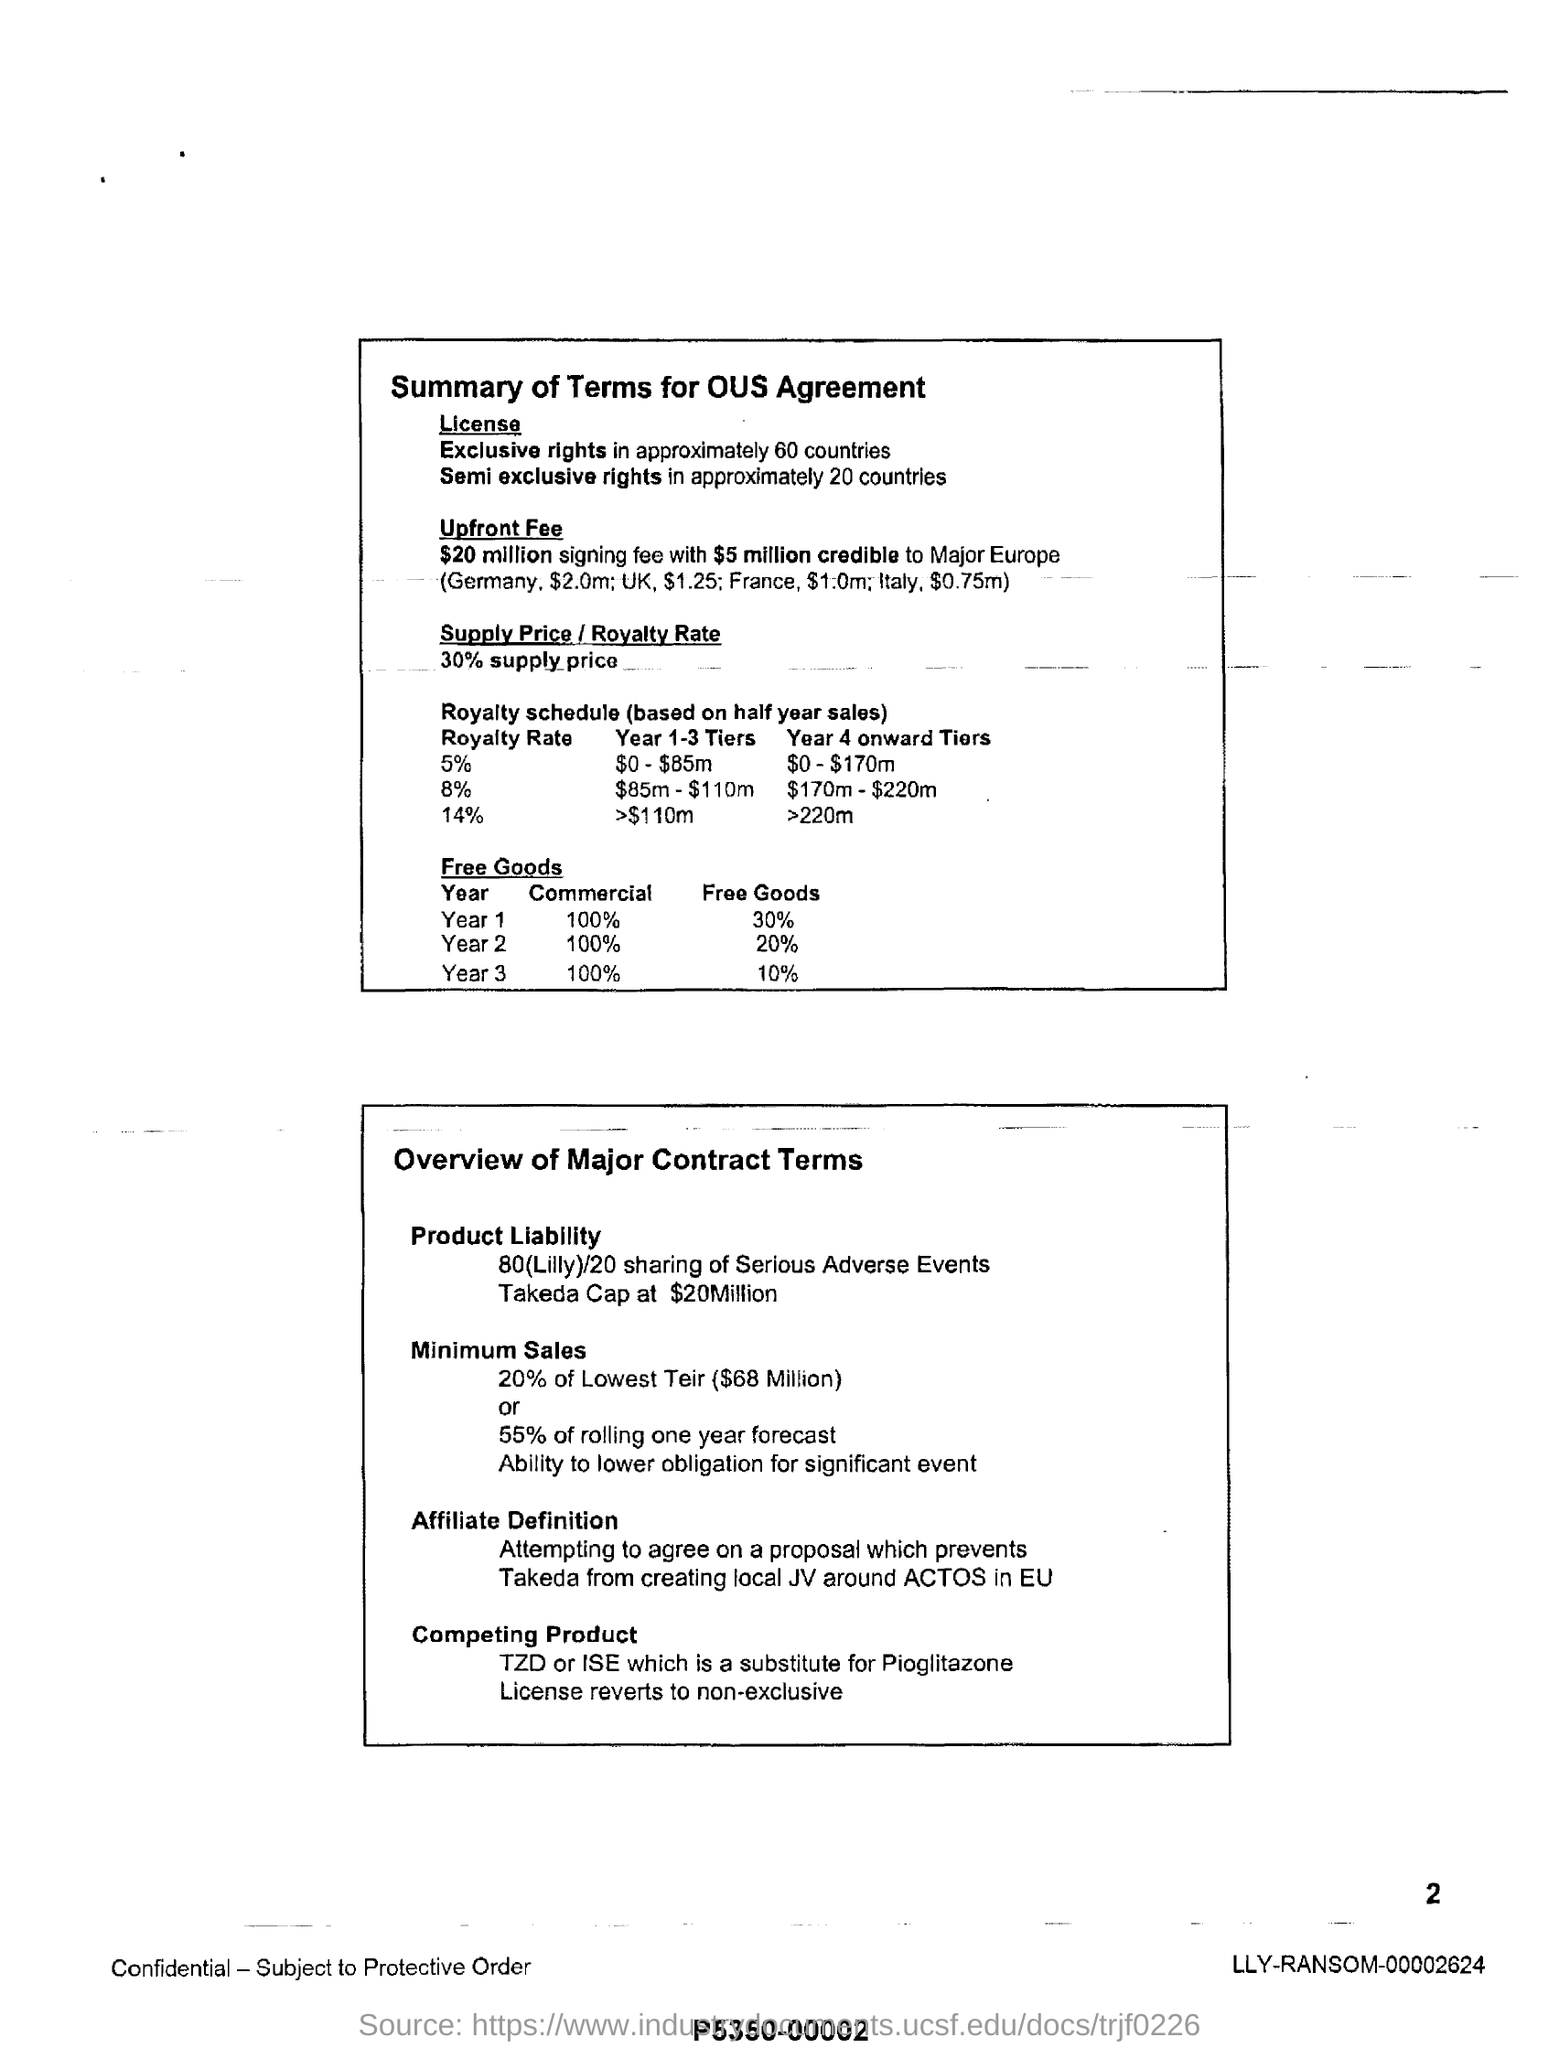Semi exclusive rights in how many countries?
Provide a short and direct response. 20. What percent is the Supply Price / Royalty Rate?
Ensure brevity in your answer.  30% supply price. In how many countires, license to Exclusive rights are provided?
Give a very brief answer. 60. 